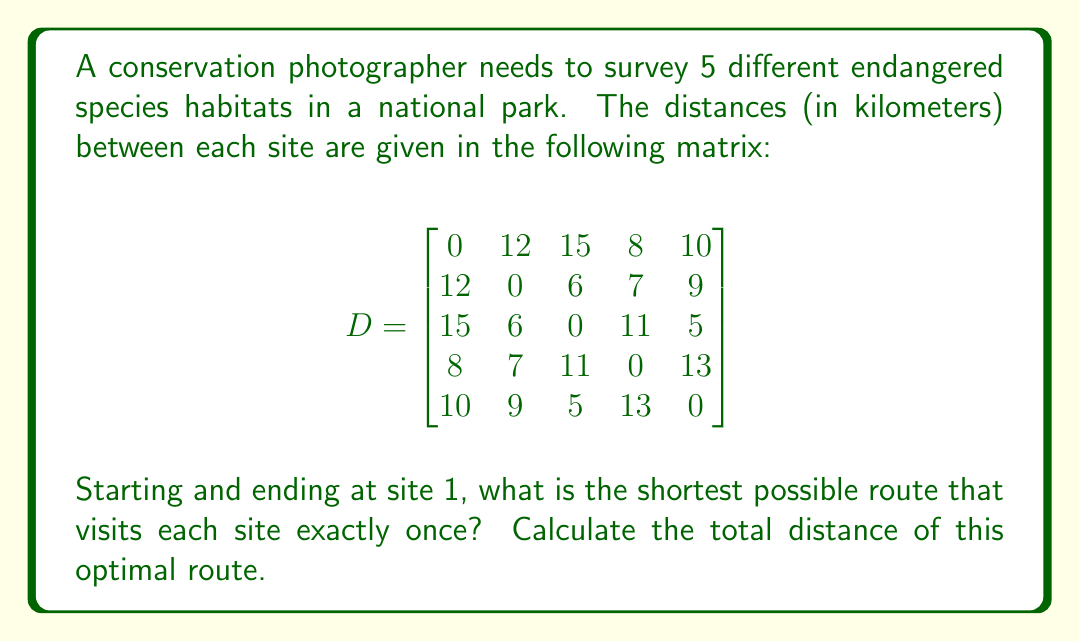Could you help me with this problem? This problem is an instance of the Traveling Salesman Problem (TSP), which can be solved using various methods. For a small number of sites like this, we can use the brute force method to find the optimal solution.

Steps to solve:
1. List all possible permutations of sites 2, 3, 4, and 5 (we fix site 1 as the start and end).
2. For each permutation, calculate the total distance of the route.
3. Choose the permutation with the shortest total distance.

Possible permutations:
1. 1-2-3-4-5-1
2. 1-2-3-5-4-1
3. 1-2-4-3-5-1
4. 1-2-4-5-3-1
5. 1-2-5-3-4-1
6. 1-2-5-4-3-1
7. 1-3-2-4-5-1
8. 1-3-2-5-4-1
9. 1-3-4-2-5-1
10. 1-3-4-5-2-1
11. 1-3-5-2-4-1
12. 1-3-5-4-2-1
13. 1-4-2-3-5-1
14. 1-4-2-5-3-1
15. 1-4-3-2-5-1
16. 1-4-3-5-2-1
17. 1-4-5-2-3-1
18. 1-4-5-3-2-1
19. 1-5-2-3-4-1
20. 1-5-2-4-3-1
21. 1-5-3-2-4-1
22. 1-5-3-4-2-1
23. 1-5-4-2-3-1
24. 1-5-4-3-2-1

Calculating the distance for each permutation and comparing them, we find that the shortest route is:

1-4-2-3-5-1

The total distance of this route is:
$$ 8 + 7 + 6 + 5 + 10 = 36 \text{ km} $$
Answer: The shortest possible route is 1-4-2-3-5-1, with a total distance of 36 km. 